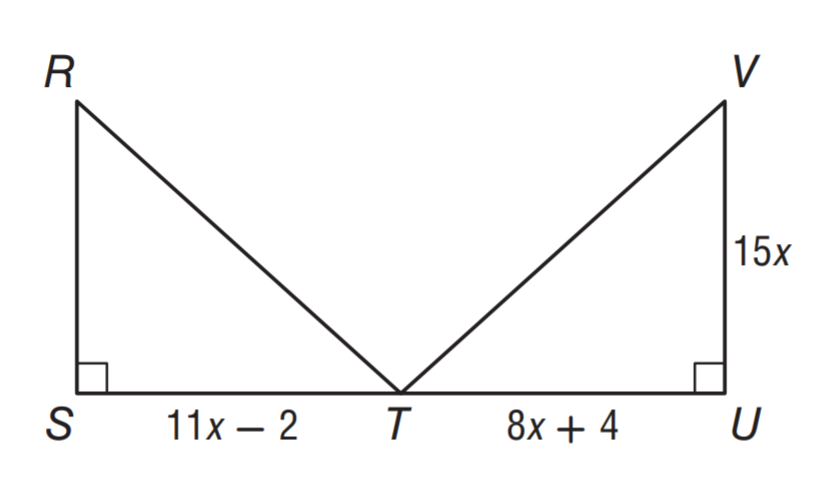Question: \triangle R S T \cong \triangle V U T. What is the area of \triangle R S T?
Choices:
A. 150
B. 300
C. 450
D. 600
Answer with the letter. Answer: B Question: \triangle R S T \cong \triangle V U T. Find x.
Choices:
A. 1
B. 2
C. 3
D. 4
Answer with the letter. Answer: B 